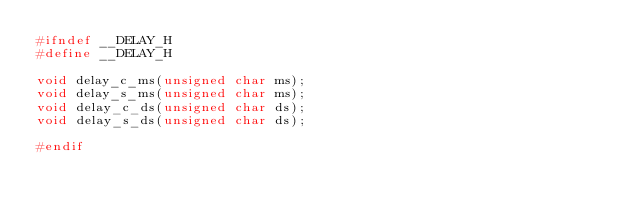<code> <loc_0><loc_0><loc_500><loc_500><_C_>#ifndef __DELAY_H
#define __DELAY_H

void delay_c_ms(unsigned char ms);
void delay_s_ms(unsigned char ms);
void delay_c_ds(unsigned char ds);
void delay_s_ds(unsigned char ds);

#endif
</code> 